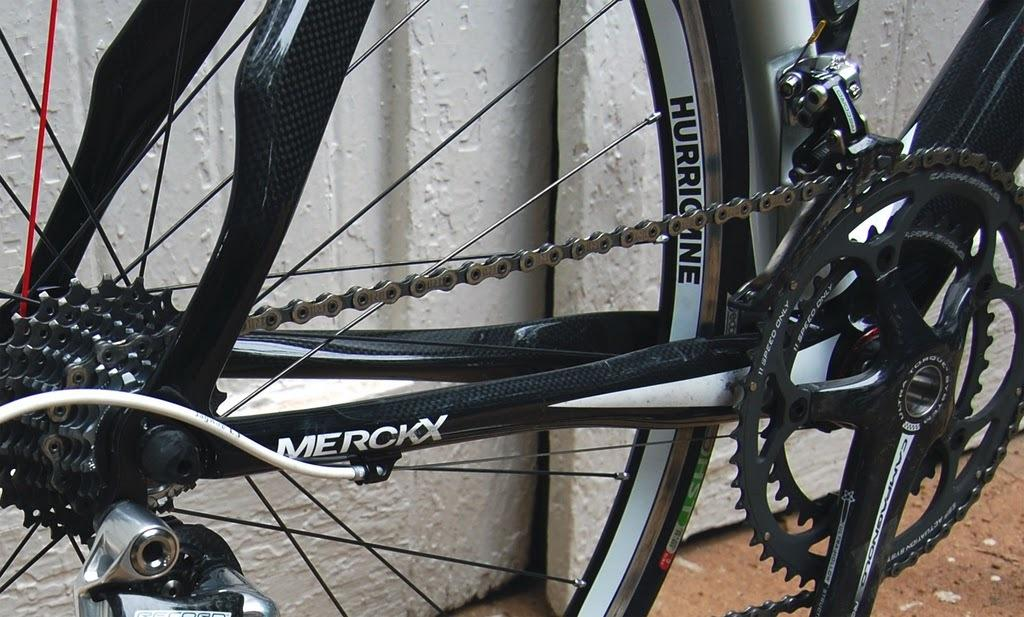What object is the main focus of the image? The main focus of the image is a wheel of a bicycle. What can be seen in the background of the image? There is a wall in the background of the image. What type of polish is being applied to the bicycle wheel in the image? There is no indication of any polish being applied to the bicycle wheel in the image. 